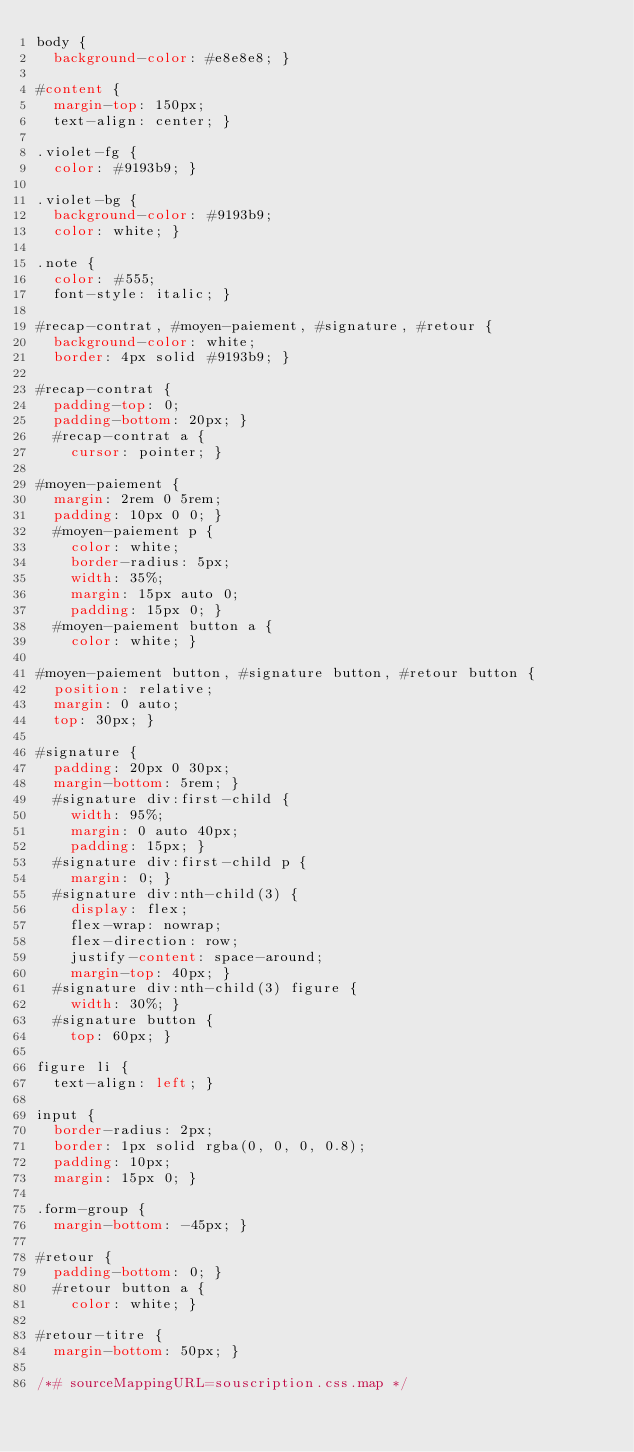<code> <loc_0><loc_0><loc_500><loc_500><_CSS_>body {
  background-color: #e8e8e8; }

#content {
  margin-top: 150px;
  text-align: center; }

.violet-fg {
  color: #9193b9; }

.violet-bg {
  background-color: #9193b9;
  color: white; }

.note {
  color: #555;
  font-style: italic; }

#recap-contrat, #moyen-paiement, #signature, #retour {
  background-color: white;
  border: 4px solid #9193b9; }

#recap-contrat {
  padding-top: 0;
  padding-bottom: 20px; }
  #recap-contrat a {
    cursor: pointer; }

#moyen-paiement {
  margin: 2rem 0 5rem;
  padding: 10px 0 0; }
  #moyen-paiement p {
    color: white;
    border-radius: 5px;
    width: 35%;
    margin: 15px auto 0;
    padding: 15px 0; }
  #moyen-paiement button a {
    color: white; }

#moyen-paiement button, #signature button, #retour button {
  position: relative;
  margin: 0 auto;
  top: 30px; }

#signature {
  padding: 20px 0 30px;
  margin-bottom: 5rem; }
  #signature div:first-child {
    width: 95%;
    margin: 0 auto 40px;
    padding: 15px; }
  #signature div:first-child p {
    margin: 0; }
  #signature div:nth-child(3) {
    display: flex;
    flex-wrap: nowrap;
    flex-direction: row;
    justify-content: space-around;
    margin-top: 40px; }
  #signature div:nth-child(3) figure {
    width: 30%; }
  #signature button {
    top: 60px; }

figure li {
  text-align: left; }

input {
  border-radius: 2px;
  border: 1px solid rgba(0, 0, 0, 0.8);
  padding: 10px;
  margin: 15px 0; }

.form-group {
  margin-bottom: -45px; }

#retour {
  padding-bottom: 0; }
  #retour button a {
    color: white; }

#retour-titre {
  margin-bottom: 50px; }

/*# sourceMappingURL=souscription.css.map */
</code> 